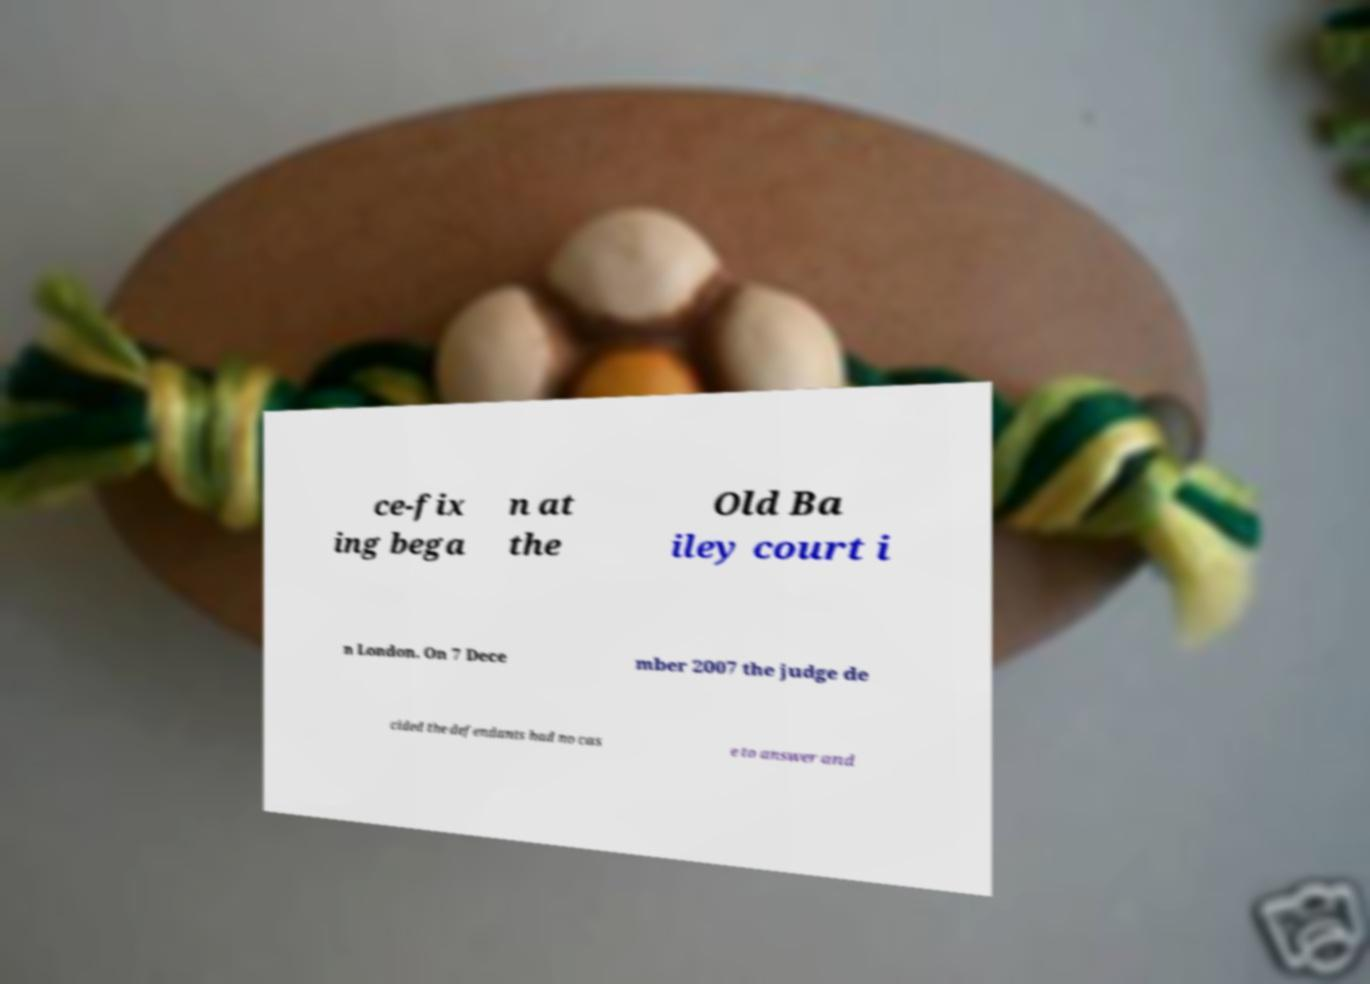There's text embedded in this image that I need extracted. Can you transcribe it verbatim? ce-fix ing bega n at the Old Ba iley court i n London. On 7 Dece mber 2007 the judge de cided the defendants had no cas e to answer and 